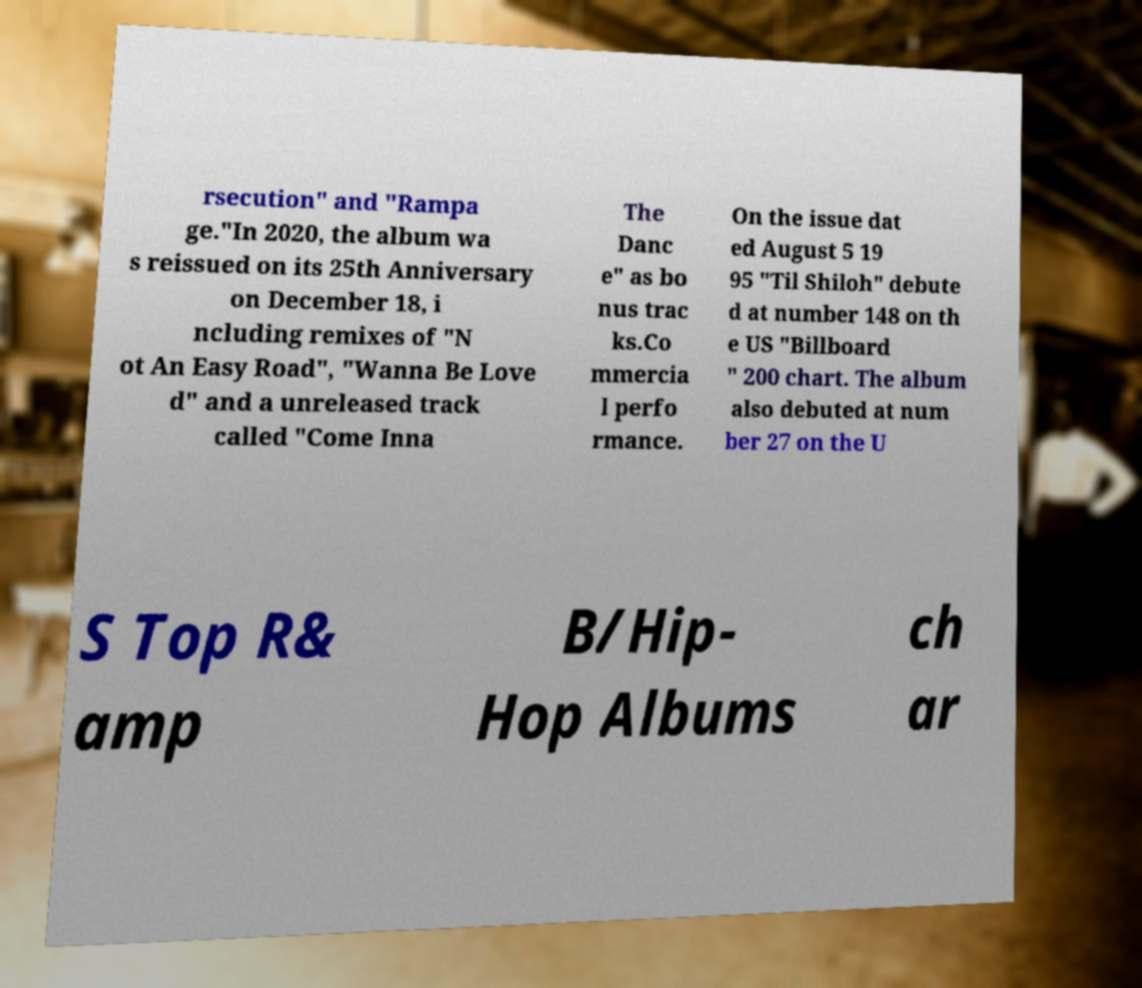There's text embedded in this image that I need extracted. Can you transcribe it verbatim? rsecution" and "Rampa ge."In 2020, the album wa s reissued on its 25th Anniversary on December 18, i ncluding remixes of "N ot An Easy Road", "Wanna Be Love d" and a unreleased track called "Come Inna The Danc e" as bo nus trac ks.Co mmercia l perfo rmance. On the issue dat ed August 5 19 95 "Til Shiloh" debute d at number 148 on th e US "Billboard " 200 chart. The album also debuted at num ber 27 on the U S Top R& amp B/Hip- Hop Albums ch ar 